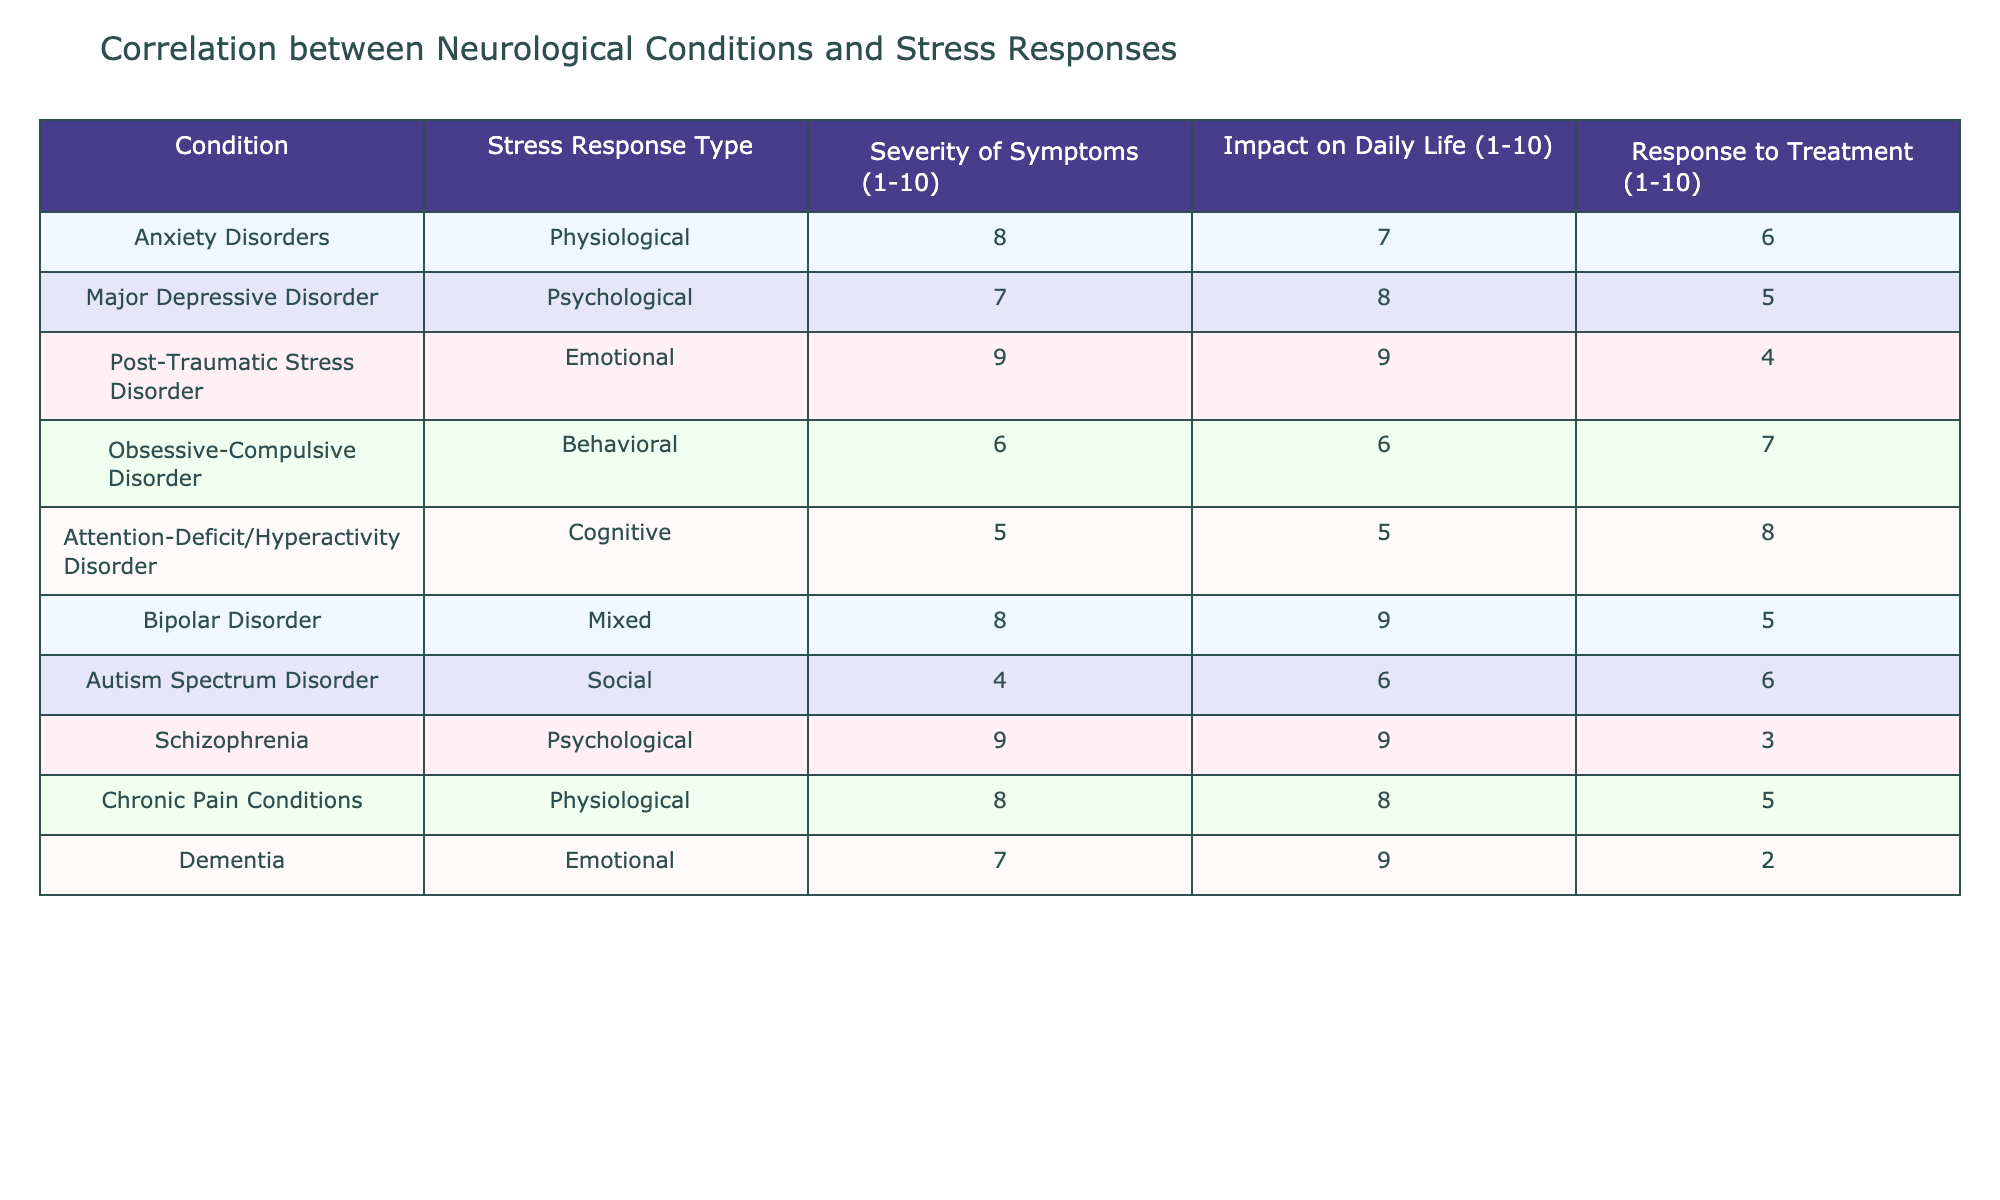What is the stress response type for Post-Traumatic Stress Disorder? The table clearly lists "Post-Traumatic Stress Disorder" under the "Condition" column with a corresponding "Stress Response Type" of "Emotional".
Answer: Emotional Which condition has the highest severity of symptoms? By reviewing the "Severity of Symptoms" column, "Post-Traumatic Stress Disorder" has the highest value at 9.
Answer: Post-Traumatic Stress Disorder What is the average impact on daily life for the conditions listed? The impact scores are 7, 8, 9, 6, 5, 9, 6, 9, 8, and 9, which sum to 66. Dividing by 10 (the number of conditions), the average is 6.6.
Answer: 6.6 Does Obsessive-Compulsive Disorder have a higher response to treatment compared to Major Depressive Disorder? The response to treatment for Obsessive-Compulsive Disorder is 7, while for Major Depressive Disorder it is 5. Since 7 is greater than 5, the statement is true.
Answer: Yes What is the total severity of symptoms for conditions with a physiological stress response type? The conditions with a physiological response are Anxiety Disorders and Chronic Pain Conditions, with severity values of 8 and 8, respectively. The total is 8 + 8 = 16.
Answer: 16 Is there a condition that has both the highest severity of symptoms and impact on daily life? Checking the "Severity of Symptoms" and "Impact on Daily Life" values, "Post-Traumatic Stress Disorder" has severity (9) and impact (9), which are the highest values compared to all conditions. Thus, yes, it is true.
Answer: Yes What is the difference in severity of symptoms between Schizophrenia and Autism Spectrum Disorder? Schizophrenia has a severity value of 9 and Autism Spectrum Disorder has 4. The difference is 9 - 4 = 5.
Answer: 5 Which disorder has the lowest impact on daily life, and what is its severity score? Reviewing the "Impact on Daily Life" column, Autism Spectrum Disorder has the lowest score at 6. Its severity score is 4, according to the table.
Answer: Autism Spectrum Disorder, Severity 4 